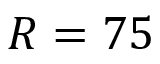<formula> <loc_0><loc_0><loc_500><loc_500>R = 7 5</formula> 